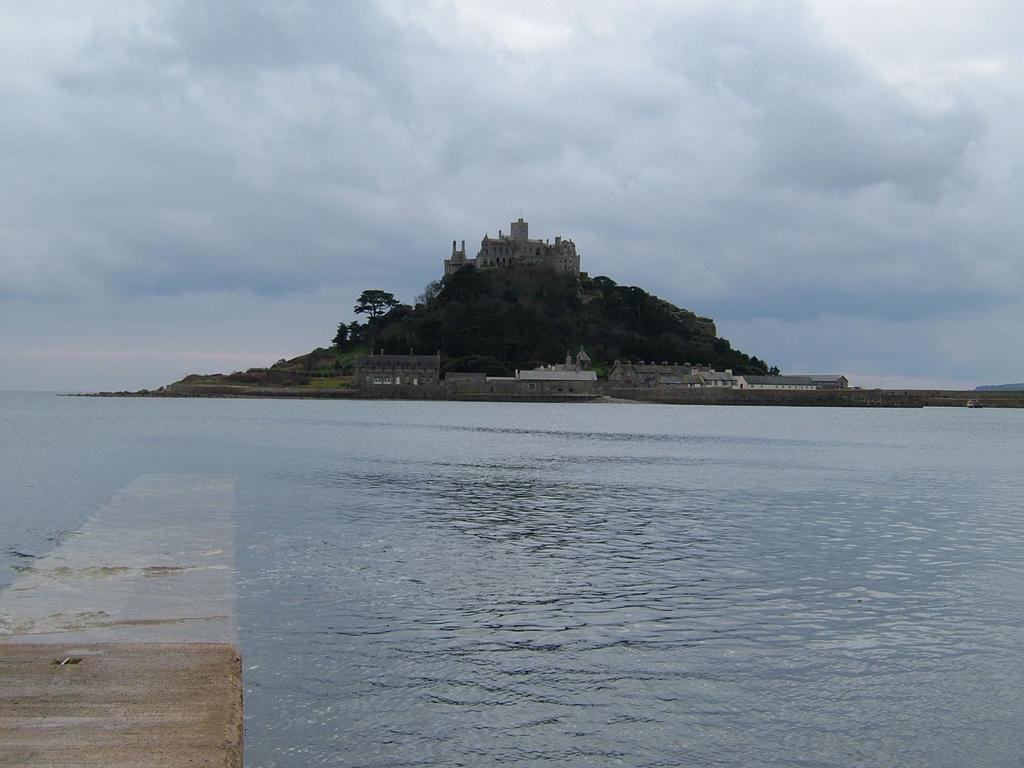What type of structures can be seen on the hill in the image? There are buildings on a hill in the image. What other natural elements are present in the image? There are trees and water visible in the image. What is visible in the background of the image? The sky is visible in the image, and clouds are present in the sky. How many apples are hanging from the trees in the image? There are no apples present in the image; it features trees without any visible fruit. What type of farm can be seen in the image? There is no farm present in the image; it features buildings on a hill, trees, water, and a sky with clouds. 